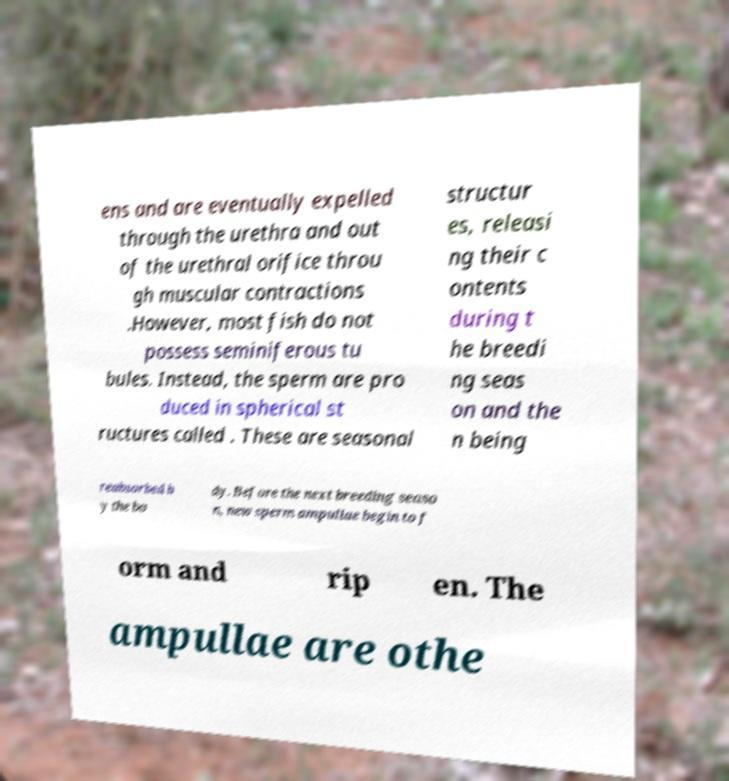Could you assist in decoding the text presented in this image and type it out clearly? ens and are eventually expelled through the urethra and out of the urethral orifice throu gh muscular contractions .However, most fish do not possess seminiferous tu bules. Instead, the sperm are pro duced in spherical st ructures called . These are seasonal structur es, releasi ng their c ontents during t he breedi ng seas on and the n being reabsorbed b y the bo dy. Before the next breeding seaso n, new sperm ampullae begin to f orm and rip en. The ampullae are othe 